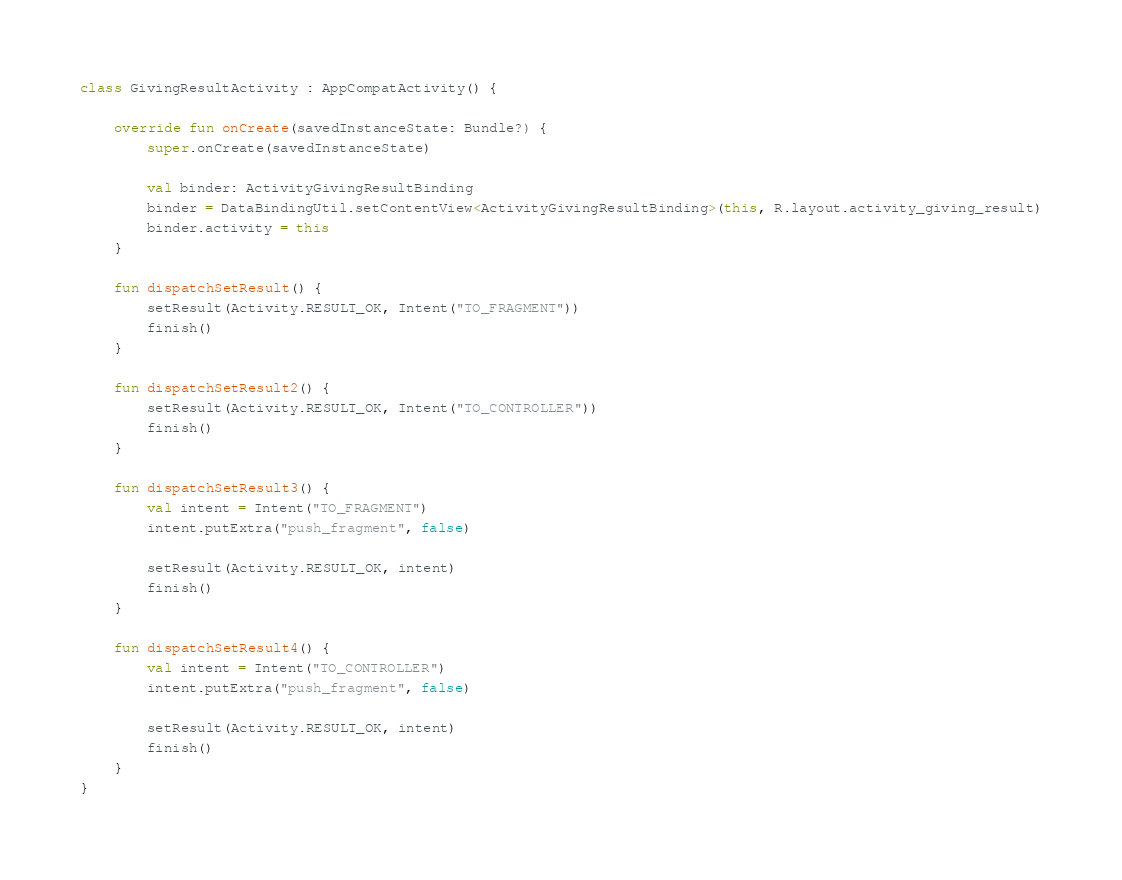<code> <loc_0><loc_0><loc_500><loc_500><_Kotlin_>
class GivingResultActivity : AppCompatActivity() {

    override fun onCreate(savedInstanceState: Bundle?) {
        super.onCreate(savedInstanceState)

        val binder: ActivityGivingResultBinding
        binder = DataBindingUtil.setContentView<ActivityGivingResultBinding>(this, R.layout.activity_giving_result)
        binder.activity = this
    }

    fun dispatchSetResult() {
        setResult(Activity.RESULT_OK, Intent("TO_FRAGMENT"))
        finish()
    }

    fun dispatchSetResult2() {
        setResult(Activity.RESULT_OK, Intent("TO_CONTROLLER"))
        finish()
    }

    fun dispatchSetResult3() {
        val intent = Intent("TO_FRAGMENT")
        intent.putExtra("push_fragment", false)

        setResult(Activity.RESULT_OK, intent)
        finish()
    }

    fun dispatchSetResult4() {
        val intent = Intent("TO_CONTROLLER")
        intent.putExtra("push_fragment", false)

        setResult(Activity.RESULT_OK, intent)
        finish()
    }
}
</code> 